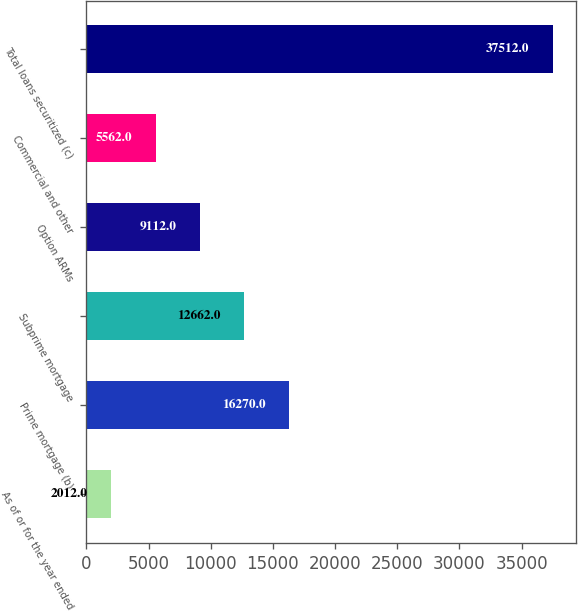Convert chart. <chart><loc_0><loc_0><loc_500><loc_500><bar_chart><fcel>As of or for the year ended<fcel>Prime mortgage (b)<fcel>Subprime mortgage<fcel>Option ARMs<fcel>Commercial and other<fcel>Total loans securitized (c)<nl><fcel>2012<fcel>16270<fcel>12662<fcel>9112<fcel>5562<fcel>37512<nl></chart> 